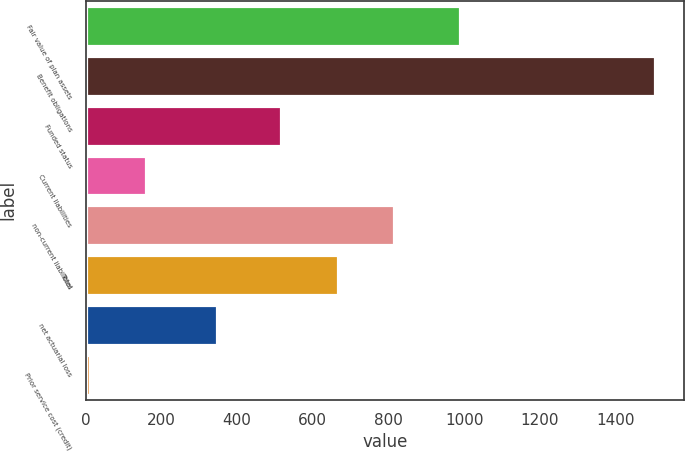<chart> <loc_0><loc_0><loc_500><loc_500><bar_chart><fcel>Fair value of plan assets<fcel>Benefit obligations<fcel>Funded status<fcel>Current liabilities<fcel>non-current liabilities<fcel>Total<fcel>net actuarial loss<fcel>Prior service cost (credit)<nl><fcel>989<fcel>1505<fcel>516<fcel>159.5<fcel>815<fcel>665.5<fcel>348<fcel>10<nl></chart> 